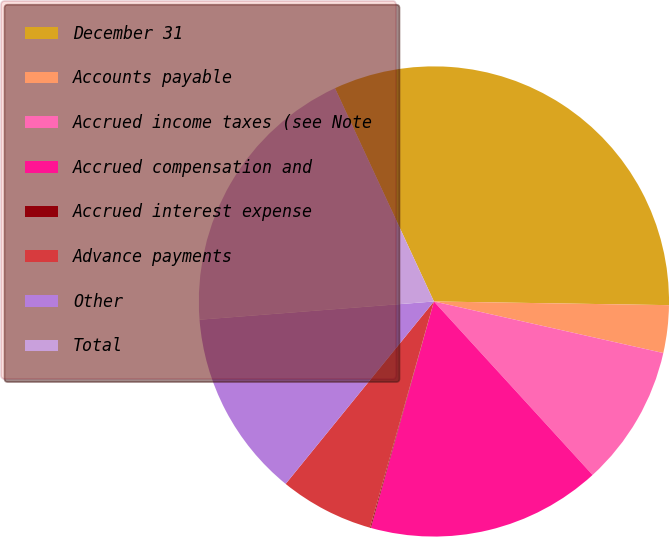<chart> <loc_0><loc_0><loc_500><loc_500><pie_chart><fcel>December 31<fcel>Accounts payable<fcel>Accrued income taxes (see Note<fcel>Accrued compensation and<fcel>Accrued interest expense<fcel>Advance payments<fcel>Other<fcel>Total<nl><fcel>32.16%<fcel>3.27%<fcel>9.69%<fcel>16.11%<fcel>0.06%<fcel>6.48%<fcel>12.9%<fcel>19.32%<nl></chart> 